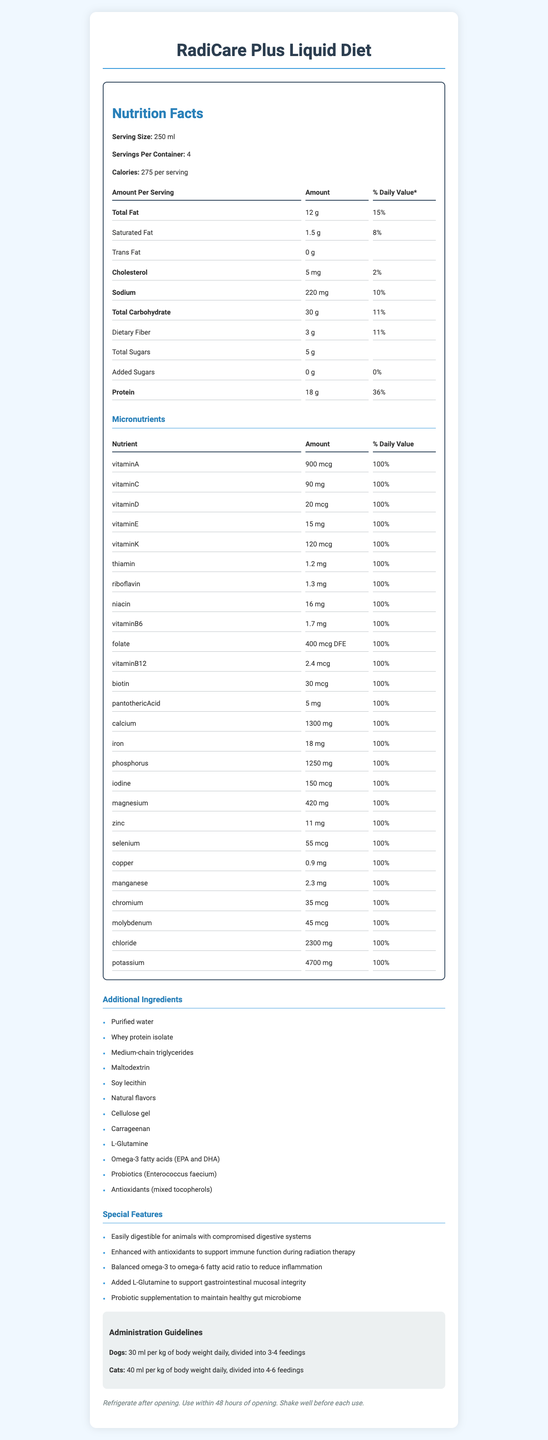What is the serving size of RadiCare Plus Liquid Diet? The serving size is listed as "250 ml" in the document.
Answer: 250 ml How many servings are there per container? The document specifies that there are 4 servings per container.
Answer: 4 How many calories are there per serving? The number of calories per serving is indicated as 275.
Answer: 275 List at least three additional ingredients found in RadiCare Plus Liquid Diet. These ingredients are listed under the "Additional Ingredients" section.
Answer: Purified water, Whey protein isolate, Medium-chain triglycerides How much protein is there per serving, and what percentage of the daily value does it provide? The nutritional facts state that each serving contains 18 grams of protein, which is 36% of the daily value.
Answer: 18 g, 36% How much calcium is provided per serving? According to the document, each serving contains 1300 mg of calcium.
Answer: 1300 mg What is the amount of Sodium per serving, and what percentage of the daily value does it represent? The label shows that each serving has 220 mg of sodium, constituting 10% of the daily value.
Answer: 220 mg, 10% What is the intended use of this liquid diet? The title and special features mention that this liquid diet is designed for animals recovering from radiation therapy.
Answer: For animals recovering from radiation therapy Which of the following special features is NOT mentioned in the document?
A. Enhanced with antioxidants
B. High in simple sugars
C. Balanced omega-3 to omega-6 ratio
D. Probiotic supplementation to maintain gut microbiome The document does not mention that the diet is high in simple sugars.
Answer: B How many daily feedings are recommended for dogs? 
1. 1-2
2. 3-4
3. 4-5
4. 5-6 The administration guidelines state that dogs should have 3-4 feedings daily.
Answer: 2 Is Lamb protein listed as one of the additional ingredients? Lamb protein is not mentioned in the list of additional ingredients.
Answer: No Summarize the main idea of the document. The document addresses various aspects, including the nutrient profile, special features beneficial during radiation therapy recovery, and guidelines for administration and storage.
Answer: The document provides detailed nutritional information for RadiCare Plus Liquid Diet, a veterinary-exclusive liquid diet for animals recovering from radiation therapy. It includes servings, macronutrient and micronutrient content, additional ingredients, special features, administration guidelines, and storage instructions. What is the ratio of omega-3 to omega-6 fatty acids in the product? The document mentions a balanced omega-3 to omega-6 fatty acid ratio but does not provide the specific ratio.
Answer: Cannot be determined 